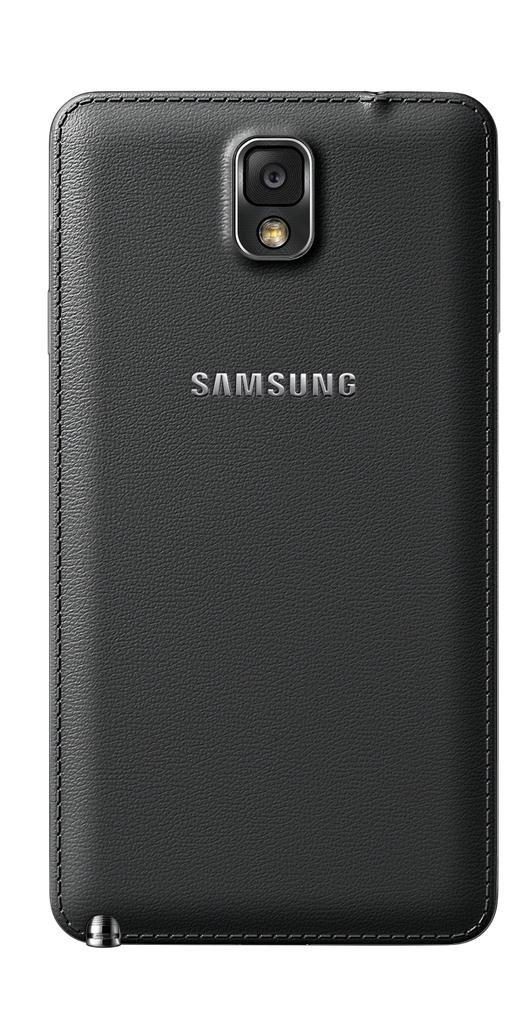<image>
Summarize the visual content of the image. Samsung manufactures smart phones which feature camera and flashlight modes. 